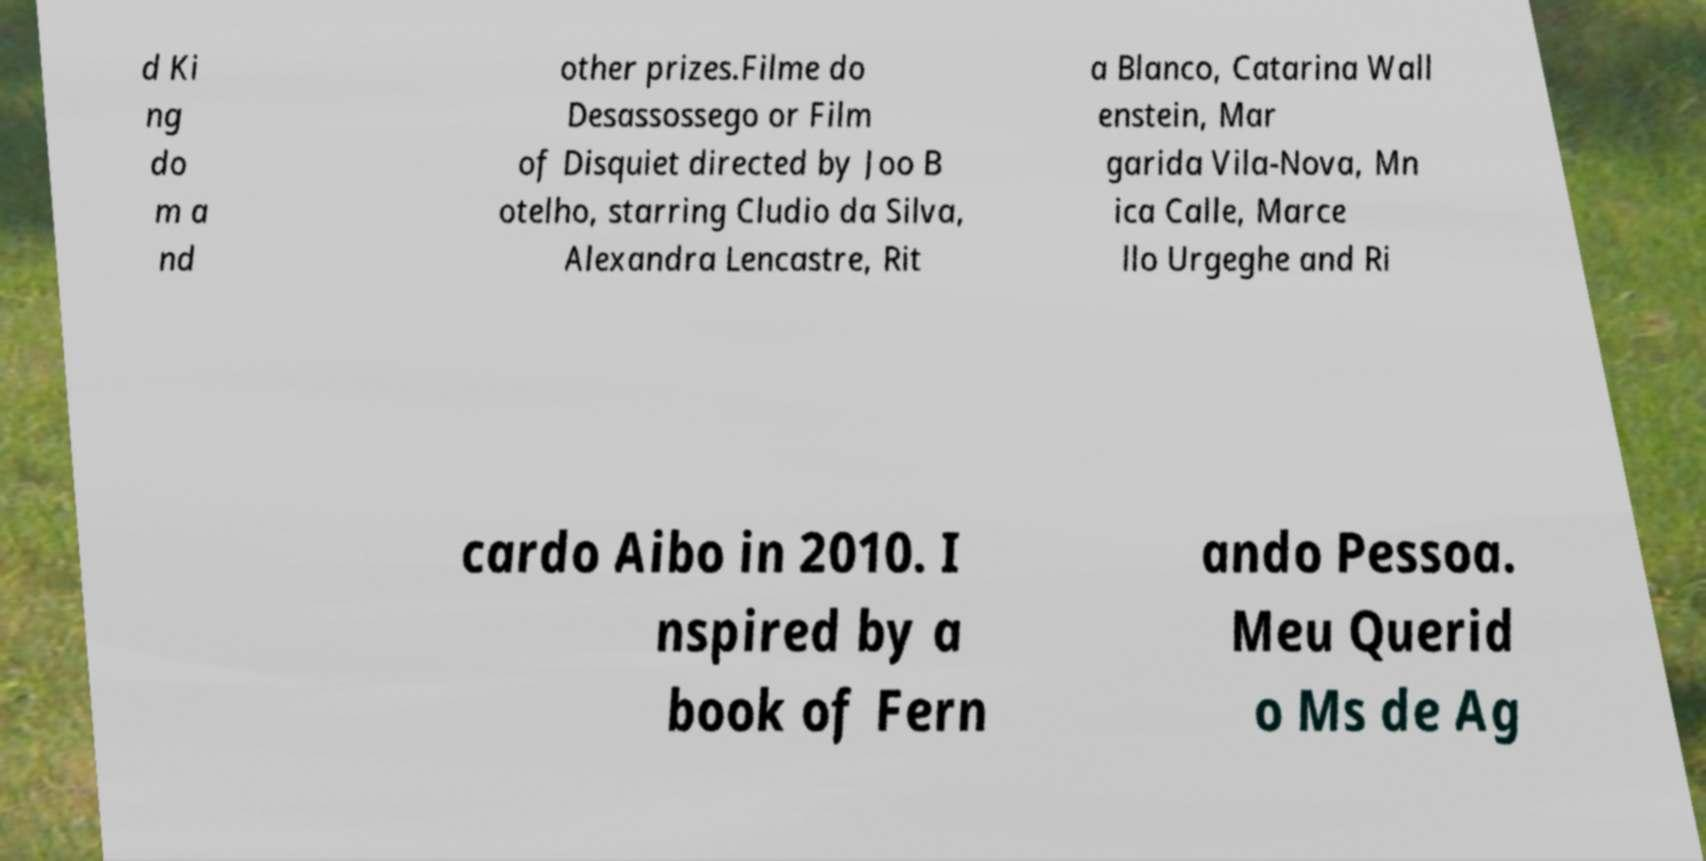Can you accurately transcribe the text from the provided image for me? d Ki ng do m a nd other prizes.Filme do Desassossego or Film of Disquiet directed by Joo B otelho, starring Cludio da Silva, Alexandra Lencastre, Rit a Blanco, Catarina Wall enstein, Mar garida Vila-Nova, Mn ica Calle, Marce llo Urgeghe and Ri cardo Aibo in 2010. I nspired by a book of Fern ando Pessoa. Meu Querid o Ms de Ag 